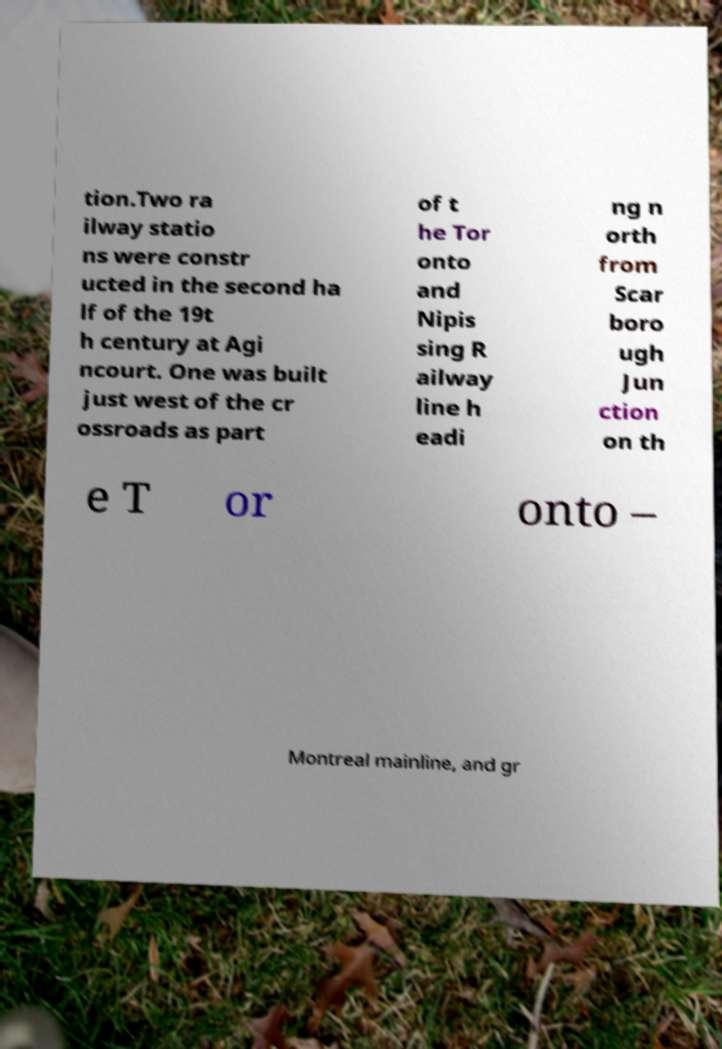There's text embedded in this image that I need extracted. Can you transcribe it verbatim? tion.Two ra ilway statio ns were constr ucted in the second ha lf of the 19t h century at Agi ncourt. One was built just west of the cr ossroads as part of t he Tor onto and Nipis sing R ailway line h eadi ng n orth from Scar boro ugh Jun ction on th e T or onto – Montreal mainline, and gr 